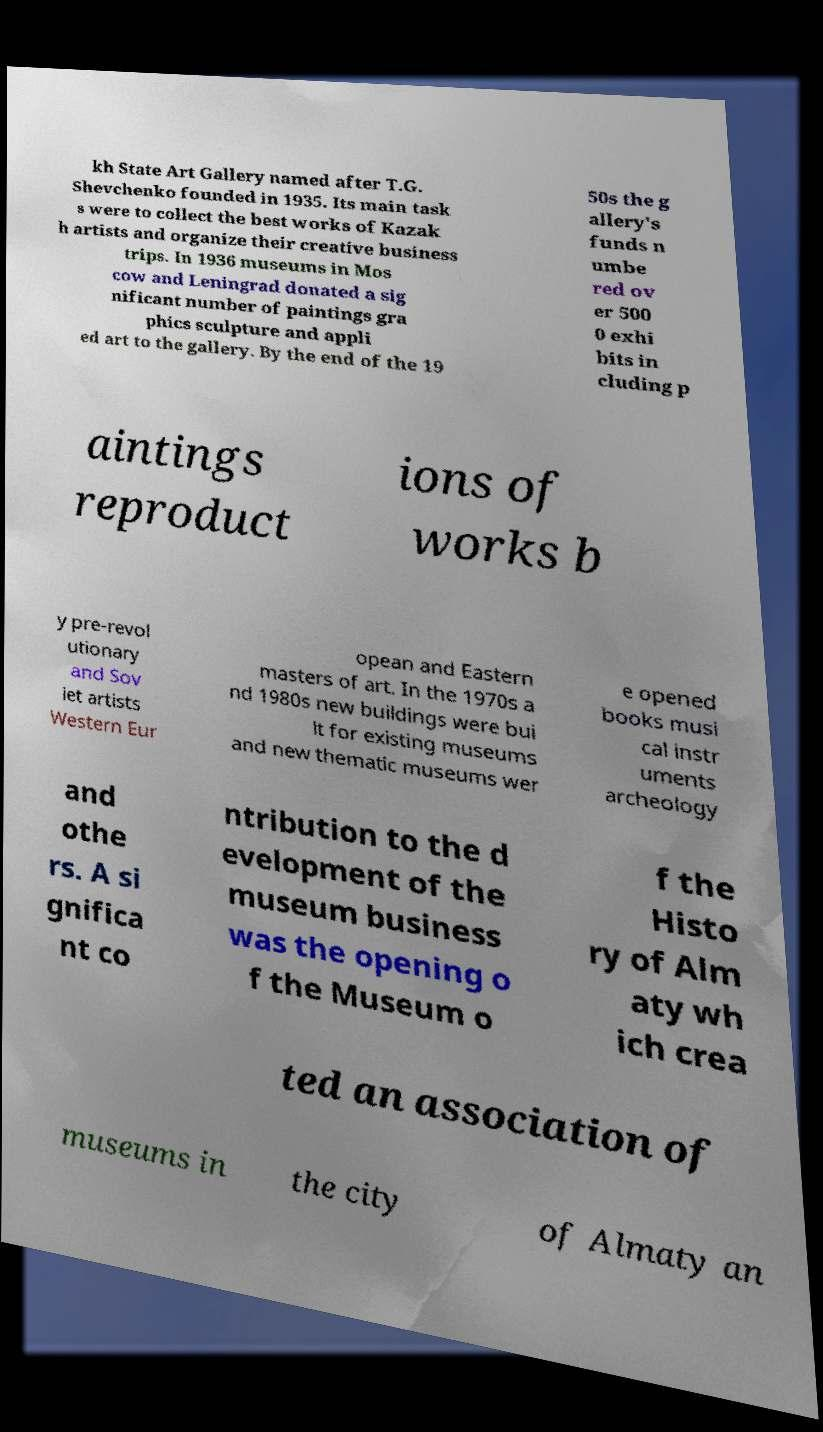Could you assist in decoding the text presented in this image and type it out clearly? kh State Art Gallery named after T.G. Shevchenko founded in 1935. Its main task s were to collect the best works of Kazak h artists and organize their creative business trips. In 1936 museums in Mos cow and Leningrad donated a sig nificant number of paintings gra phics sculpture and appli ed art to the gallery. By the end of the 19 50s the g allery's funds n umbe red ov er 500 0 exhi bits in cluding p aintings reproduct ions of works b y pre-revol utionary and Sov iet artists Western Eur opean and Eastern masters of art. In the 1970s a nd 1980s new buildings were bui lt for existing museums and new thematic museums wer e opened books musi cal instr uments archeology and othe rs. A si gnifica nt co ntribution to the d evelopment of the museum business was the opening o f the Museum o f the Histo ry of Alm aty wh ich crea ted an association of museums in the city of Almaty an 